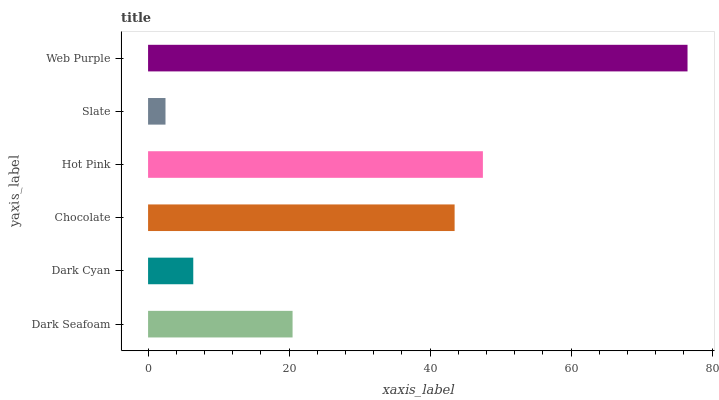Is Slate the minimum?
Answer yes or no. Yes. Is Web Purple the maximum?
Answer yes or no. Yes. Is Dark Cyan the minimum?
Answer yes or no. No. Is Dark Cyan the maximum?
Answer yes or no. No. Is Dark Seafoam greater than Dark Cyan?
Answer yes or no. Yes. Is Dark Cyan less than Dark Seafoam?
Answer yes or no. Yes. Is Dark Cyan greater than Dark Seafoam?
Answer yes or no. No. Is Dark Seafoam less than Dark Cyan?
Answer yes or no. No. Is Chocolate the high median?
Answer yes or no. Yes. Is Dark Seafoam the low median?
Answer yes or no. Yes. Is Hot Pink the high median?
Answer yes or no. No. Is Chocolate the low median?
Answer yes or no. No. 